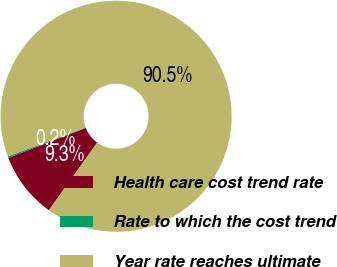<chart> <loc_0><loc_0><loc_500><loc_500><pie_chart><fcel>Health care cost trend rate<fcel>Rate to which the cost trend<fcel>Year rate reaches ultimate<nl><fcel>9.25%<fcel>0.22%<fcel>90.52%<nl></chart> 